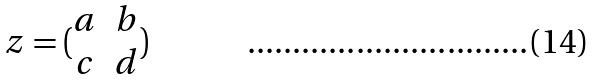Convert formula to latex. <formula><loc_0><loc_0><loc_500><loc_500>z = ( \begin{matrix} a & b \\ c & d \end{matrix} )</formula> 